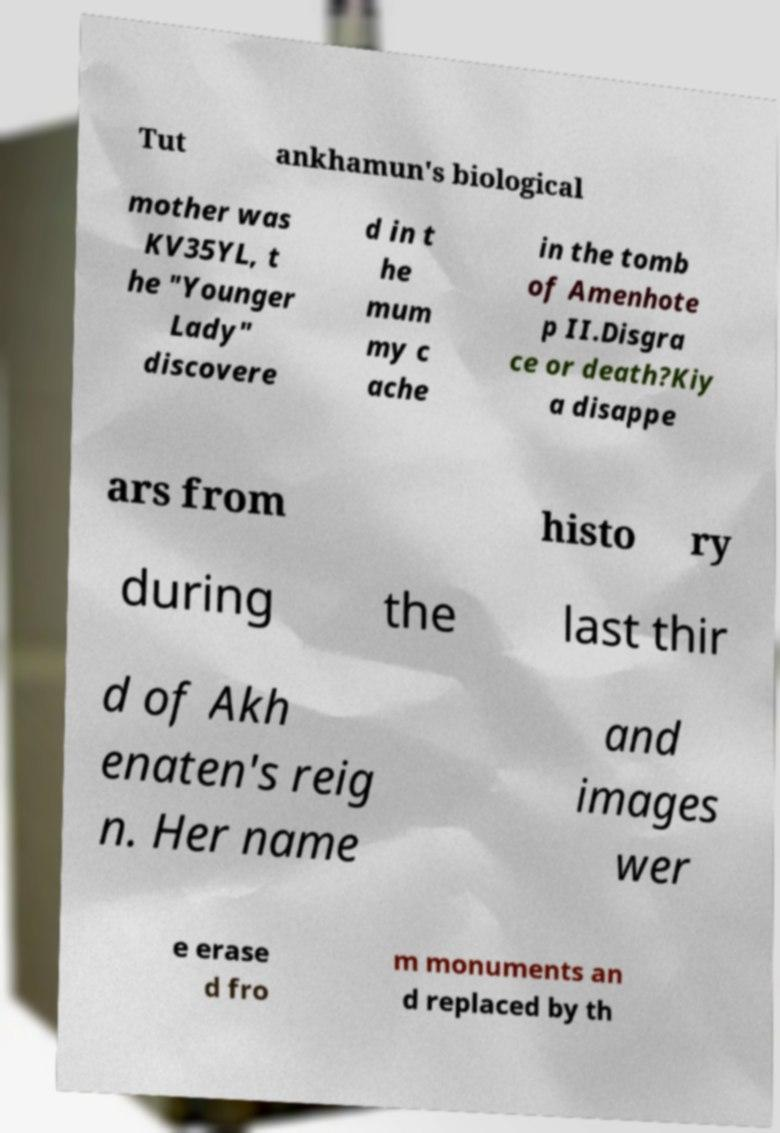Could you extract and type out the text from this image? Tut ankhamun's biological mother was KV35YL, t he "Younger Lady" discovere d in t he mum my c ache in the tomb of Amenhote p II.Disgra ce or death?Kiy a disappe ars from histo ry during the last thir d of Akh enaten's reig n. Her name and images wer e erase d fro m monuments an d replaced by th 